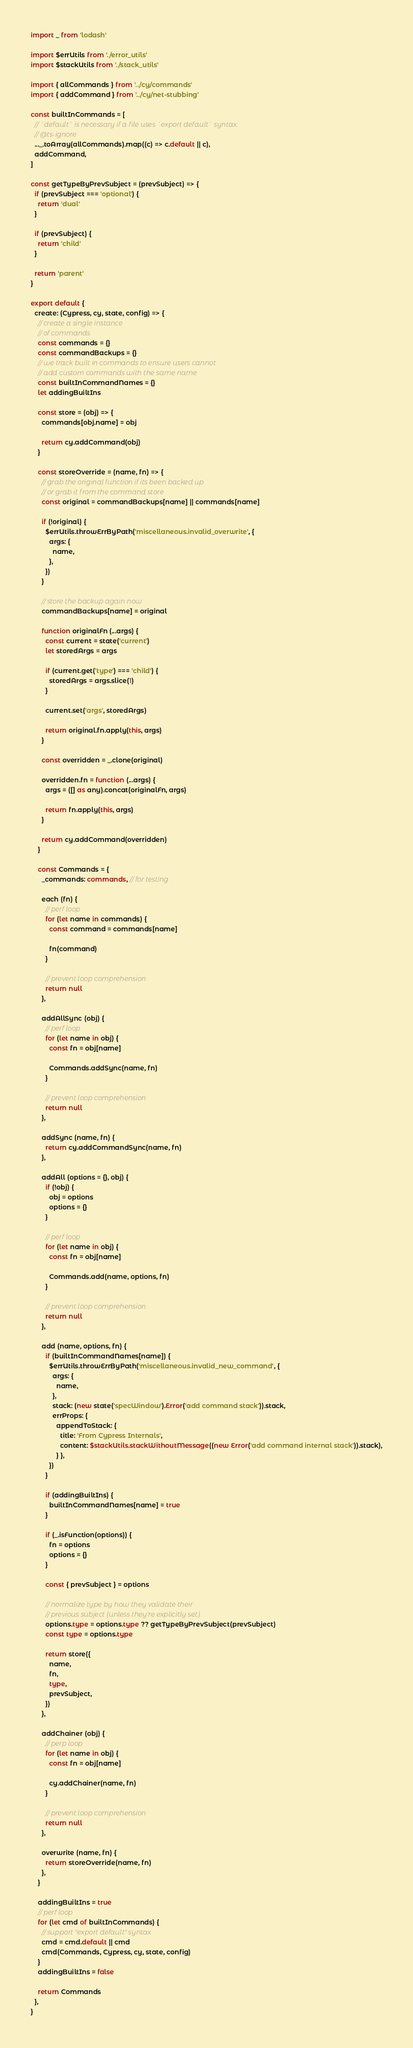<code> <loc_0><loc_0><loc_500><loc_500><_TypeScript_>import _ from 'lodash'

import $errUtils from './error_utils'
import $stackUtils from './stack_utils'

import { allCommands } from '../cy/commands'
import { addCommand } from '../cy/net-stubbing'

const builtInCommands = [
  // `default` is necessary if a file uses `export default` syntax.
  // @ts-ignore
  ..._.toArray(allCommands).map((c) => c.default || c),
  addCommand,
]

const getTypeByPrevSubject = (prevSubject) => {
  if (prevSubject === 'optional') {
    return 'dual'
  }

  if (prevSubject) {
    return 'child'
  }

  return 'parent'
}

export default {
  create: (Cypress, cy, state, config) => {
    // create a single instance
    // of commands
    const commands = {}
    const commandBackups = {}
    // we track built in commands to ensure users cannot
    // add custom commands with the same name
    const builtInCommandNames = {}
    let addingBuiltIns

    const store = (obj) => {
      commands[obj.name] = obj

      return cy.addCommand(obj)
    }

    const storeOverride = (name, fn) => {
      // grab the original function if its been backed up
      // or grab it from the command store
      const original = commandBackups[name] || commands[name]

      if (!original) {
        $errUtils.throwErrByPath('miscellaneous.invalid_overwrite', {
          args: {
            name,
          },
        })
      }

      // store the backup again now
      commandBackups[name] = original

      function originalFn (...args) {
        const current = state('current')
        let storedArgs = args

        if (current.get('type') === 'child') {
          storedArgs = args.slice(1)
        }

        current.set('args', storedArgs)

        return original.fn.apply(this, args)
      }

      const overridden = _.clone(original)

      overridden.fn = function (...args) {
        args = ([] as any).concat(originalFn, args)

        return fn.apply(this, args)
      }

      return cy.addCommand(overridden)
    }

    const Commands = {
      _commands: commands, // for testing

      each (fn) {
        // perf loop
        for (let name in commands) {
          const command = commands[name]

          fn(command)
        }

        // prevent loop comprehension
        return null
      },

      addAllSync (obj) {
        // perf loop
        for (let name in obj) {
          const fn = obj[name]

          Commands.addSync(name, fn)
        }

        // prevent loop comprehension
        return null
      },

      addSync (name, fn) {
        return cy.addCommandSync(name, fn)
      },

      addAll (options = {}, obj) {
        if (!obj) {
          obj = options
          options = {}
        }

        // perf loop
        for (let name in obj) {
          const fn = obj[name]

          Commands.add(name, options, fn)
        }

        // prevent loop comprehension
        return null
      },

      add (name, options, fn) {
        if (builtInCommandNames[name]) {
          $errUtils.throwErrByPath('miscellaneous.invalid_new_command', {
            args: {
              name,
            },
            stack: (new state('specWindow').Error('add command stack')).stack,
            errProps: {
              appendToStack: {
                title: 'From Cypress Internals',
                content: $stackUtils.stackWithoutMessage((new Error('add command internal stack')).stack),
              } },
          })
        }

        if (addingBuiltIns) {
          builtInCommandNames[name] = true
        }

        if (_.isFunction(options)) {
          fn = options
          options = {}
        }

        const { prevSubject } = options

        // normalize type by how they validate their
        // previous subject (unless they're explicitly set)
        options.type = options.type ?? getTypeByPrevSubject(prevSubject)
        const type = options.type

        return store({
          name,
          fn,
          type,
          prevSubject,
        })
      },

      addChainer (obj) {
        // perp loop
        for (let name in obj) {
          const fn = obj[name]

          cy.addChainer(name, fn)
        }

        // prevent loop comprehension
        return null
      },

      overwrite (name, fn) {
        return storeOverride(name, fn)
      },
    }

    addingBuiltIns = true
    // perf loop
    for (let cmd of builtInCommands) {
      // support "export default" syntax
      cmd = cmd.default || cmd
      cmd(Commands, Cypress, cy, state, config)
    }
    addingBuiltIns = false

    return Commands
  },
}
</code> 